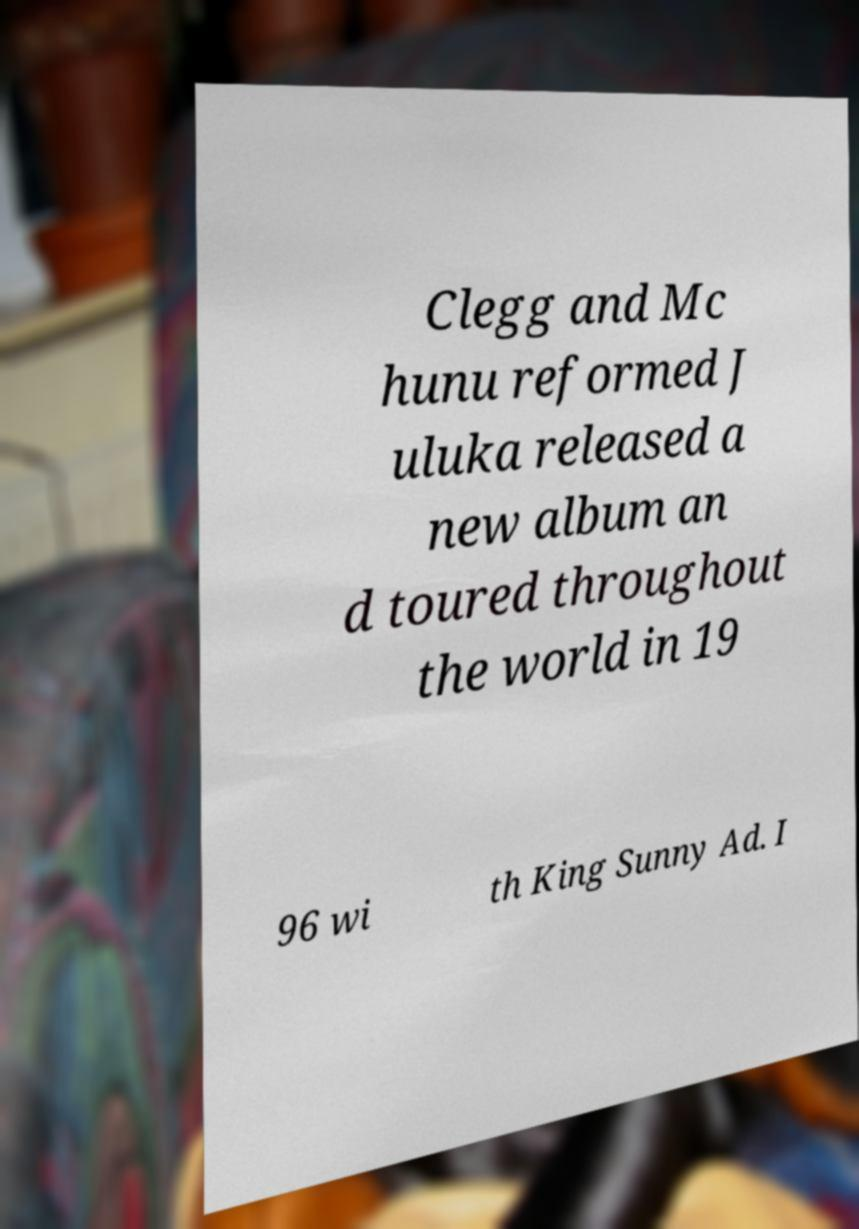There's text embedded in this image that I need extracted. Can you transcribe it verbatim? Clegg and Mc hunu reformed J uluka released a new album an d toured throughout the world in 19 96 wi th King Sunny Ad. I 